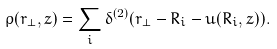Convert formula to latex. <formula><loc_0><loc_0><loc_500><loc_500>\rho ( { r } _ { \perp } , z ) = \sum _ { i } \delta ^ { ( 2 ) } ( { r } _ { \perp } - { R } _ { i } - { u } ( { R } _ { i } , z ) ) .</formula> 